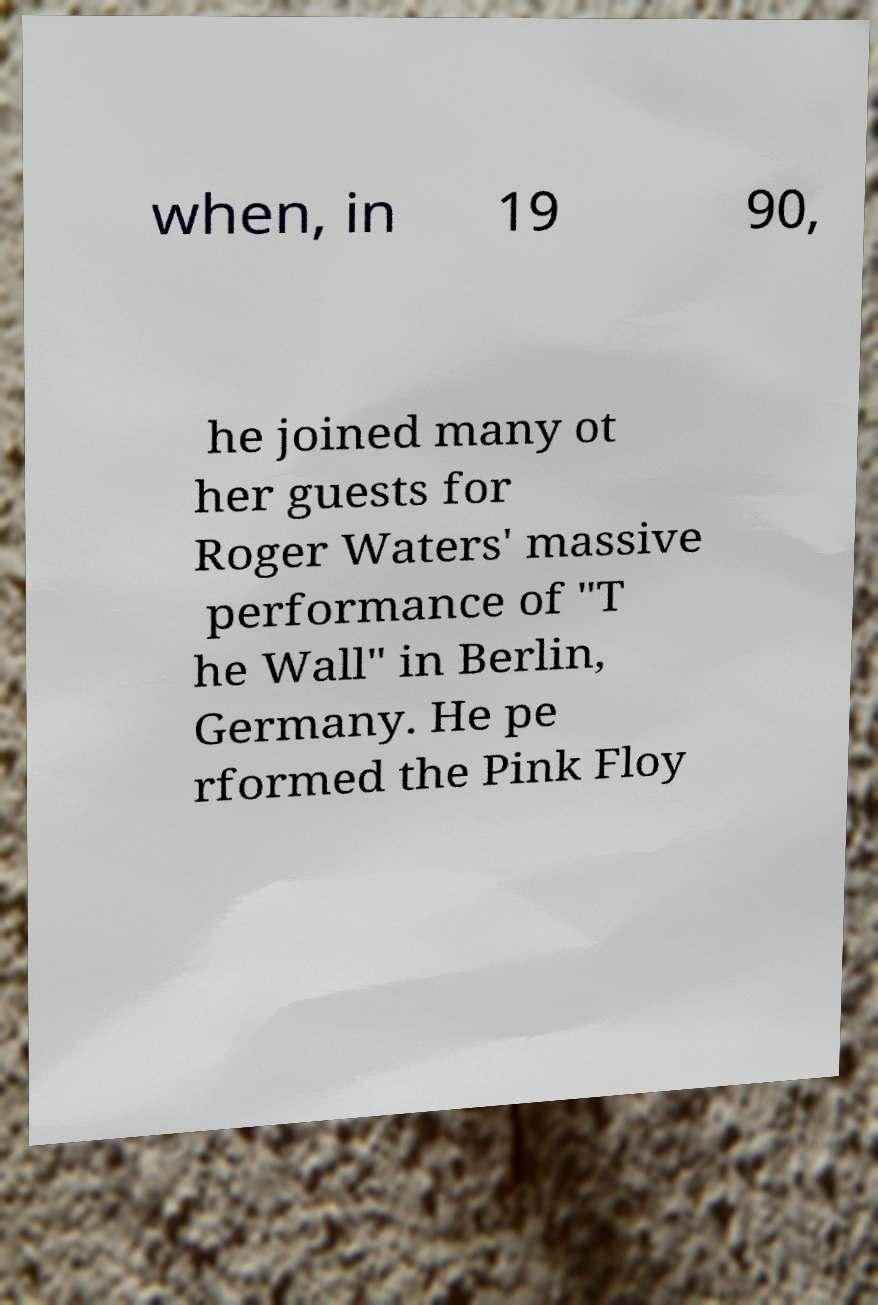Can you accurately transcribe the text from the provided image for me? when, in 19 90, he joined many ot her guests for Roger Waters' massive performance of "T he Wall" in Berlin, Germany. He pe rformed the Pink Floy 